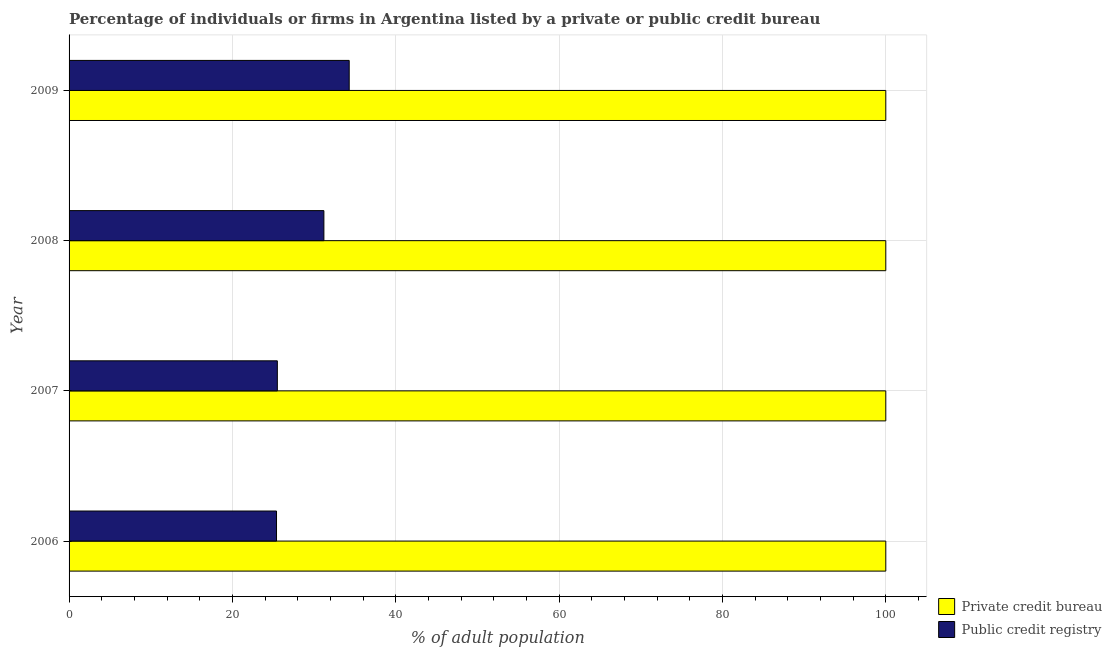How many different coloured bars are there?
Offer a very short reply. 2. How many groups of bars are there?
Provide a short and direct response. 4. Are the number of bars on each tick of the Y-axis equal?
Provide a short and direct response. Yes. How many bars are there on the 2nd tick from the bottom?
Your answer should be compact. 2. What is the percentage of firms listed by private credit bureau in 2007?
Keep it short and to the point. 100. Across all years, what is the maximum percentage of firms listed by public credit bureau?
Offer a terse response. 34.3. Across all years, what is the minimum percentage of firms listed by public credit bureau?
Your answer should be compact. 25.4. In which year was the percentage of firms listed by private credit bureau minimum?
Offer a very short reply. 2006. What is the total percentage of firms listed by public credit bureau in the graph?
Give a very brief answer. 116.4. What is the difference between the percentage of firms listed by private credit bureau in 2009 and the percentage of firms listed by public credit bureau in 2008?
Offer a terse response. 68.8. What is the average percentage of firms listed by private credit bureau per year?
Your answer should be very brief. 100. In the year 2009, what is the difference between the percentage of firms listed by public credit bureau and percentage of firms listed by private credit bureau?
Ensure brevity in your answer.  -65.7. In how many years, is the percentage of firms listed by private credit bureau greater than 12 %?
Ensure brevity in your answer.  4. What is the ratio of the percentage of firms listed by private credit bureau in 2008 to that in 2009?
Offer a very short reply. 1. Is the percentage of firms listed by public credit bureau in 2006 less than that in 2008?
Ensure brevity in your answer.  Yes. Is the difference between the percentage of firms listed by public credit bureau in 2006 and 2007 greater than the difference between the percentage of firms listed by private credit bureau in 2006 and 2007?
Keep it short and to the point. No. In how many years, is the percentage of firms listed by private credit bureau greater than the average percentage of firms listed by private credit bureau taken over all years?
Give a very brief answer. 0. What does the 2nd bar from the top in 2008 represents?
Offer a very short reply. Private credit bureau. What does the 1st bar from the bottom in 2007 represents?
Give a very brief answer. Private credit bureau. How many bars are there?
Your answer should be very brief. 8. Are all the bars in the graph horizontal?
Your answer should be very brief. Yes. How many years are there in the graph?
Your answer should be very brief. 4. Does the graph contain grids?
Provide a short and direct response. Yes. Where does the legend appear in the graph?
Your response must be concise. Bottom right. What is the title of the graph?
Your answer should be very brief. Percentage of individuals or firms in Argentina listed by a private or public credit bureau. Does "Number of departures" appear as one of the legend labels in the graph?
Provide a succinct answer. No. What is the label or title of the X-axis?
Provide a succinct answer. % of adult population. What is the label or title of the Y-axis?
Provide a short and direct response. Year. What is the % of adult population of Private credit bureau in 2006?
Ensure brevity in your answer.  100. What is the % of adult population of Public credit registry in 2006?
Offer a very short reply. 25.4. What is the % of adult population of Private credit bureau in 2008?
Give a very brief answer. 100. What is the % of adult population in Public credit registry in 2008?
Your response must be concise. 31.2. What is the % of adult population in Private credit bureau in 2009?
Give a very brief answer. 100. What is the % of adult population in Public credit registry in 2009?
Give a very brief answer. 34.3. Across all years, what is the maximum % of adult population of Public credit registry?
Give a very brief answer. 34.3. Across all years, what is the minimum % of adult population of Private credit bureau?
Your answer should be very brief. 100. Across all years, what is the minimum % of adult population of Public credit registry?
Give a very brief answer. 25.4. What is the total % of adult population in Private credit bureau in the graph?
Offer a very short reply. 400. What is the total % of adult population in Public credit registry in the graph?
Ensure brevity in your answer.  116.4. What is the difference between the % of adult population in Public credit registry in 2006 and that in 2008?
Provide a short and direct response. -5.8. What is the difference between the % of adult population in Private credit bureau in 2006 and that in 2009?
Ensure brevity in your answer.  0. What is the difference between the % of adult population of Private credit bureau in 2008 and that in 2009?
Your response must be concise. 0. What is the difference between the % of adult population of Private credit bureau in 2006 and the % of adult population of Public credit registry in 2007?
Offer a very short reply. 74.5. What is the difference between the % of adult population of Private credit bureau in 2006 and the % of adult population of Public credit registry in 2008?
Make the answer very short. 68.8. What is the difference between the % of adult population of Private credit bureau in 2006 and the % of adult population of Public credit registry in 2009?
Provide a short and direct response. 65.7. What is the difference between the % of adult population of Private credit bureau in 2007 and the % of adult population of Public credit registry in 2008?
Your response must be concise. 68.8. What is the difference between the % of adult population of Private credit bureau in 2007 and the % of adult population of Public credit registry in 2009?
Your response must be concise. 65.7. What is the difference between the % of adult population in Private credit bureau in 2008 and the % of adult population in Public credit registry in 2009?
Your answer should be very brief. 65.7. What is the average % of adult population of Public credit registry per year?
Provide a short and direct response. 29.1. In the year 2006, what is the difference between the % of adult population in Private credit bureau and % of adult population in Public credit registry?
Provide a succinct answer. 74.6. In the year 2007, what is the difference between the % of adult population of Private credit bureau and % of adult population of Public credit registry?
Your answer should be compact. 74.5. In the year 2008, what is the difference between the % of adult population of Private credit bureau and % of adult population of Public credit registry?
Provide a succinct answer. 68.8. In the year 2009, what is the difference between the % of adult population of Private credit bureau and % of adult population of Public credit registry?
Offer a terse response. 65.7. What is the ratio of the % of adult population in Private credit bureau in 2006 to that in 2007?
Provide a short and direct response. 1. What is the ratio of the % of adult population in Public credit registry in 2006 to that in 2007?
Your response must be concise. 1. What is the ratio of the % of adult population in Public credit registry in 2006 to that in 2008?
Provide a short and direct response. 0.81. What is the ratio of the % of adult population in Private credit bureau in 2006 to that in 2009?
Offer a very short reply. 1. What is the ratio of the % of adult population in Public credit registry in 2006 to that in 2009?
Offer a terse response. 0.74. What is the ratio of the % of adult population in Private credit bureau in 2007 to that in 2008?
Make the answer very short. 1. What is the ratio of the % of adult population in Public credit registry in 2007 to that in 2008?
Your answer should be very brief. 0.82. What is the ratio of the % of adult population of Private credit bureau in 2007 to that in 2009?
Your answer should be very brief. 1. What is the ratio of the % of adult population of Public credit registry in 2007 to that in 2009?
Your answer should be compact. 0.74. What is the ratio of the % of adult population of Private credit bureau in 2008 to that in 2009?
Provide a short and direct response. 1. What is the ratio of the % of adult population in Public credit registry in 2008 to that in 2009?
Ensure brevity in your answer.  0.91. What is the difference between the highest and the second highest % of adult population of Private credit bureau?
Your answer should be compact. 0. What is the difference between the highest and the second highest % of adult population of Public credit registry?
Your response must be concise. 3.1. What is the difference between the highest and the lowest % of adult population of Private credit bureau?
Your answer should be very brief. 0. What is the difference between the highest and the lowest % of adult population of Public credit registry?
Offer a terse response. 8.9. 